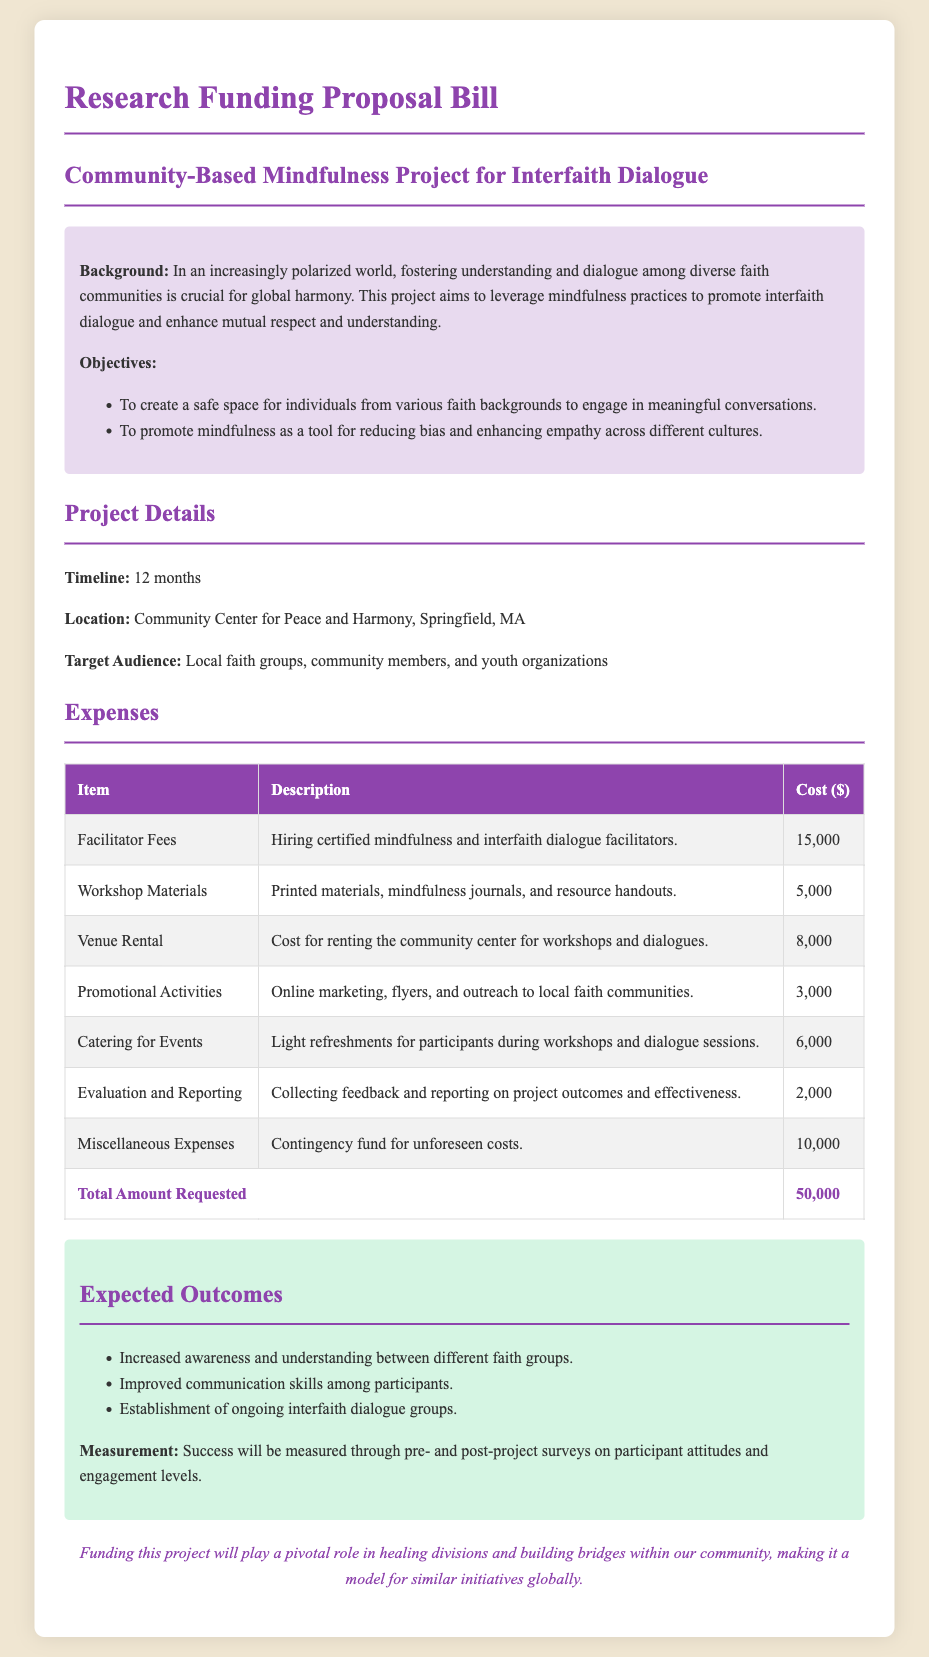What is the total amount requested? The total amount requested is clearly outlined in the expenses section of the document as the sum of all costs, which equals $50,000.
Answer: $50,000 What are the workshop materials? The workshop materials are described in the expenses section as printed materials, mindfulness journals, and resource handouts.
Answer: Printed materials, mindfulness journals, and resource handouts Where is the project located? The location of the project is stated in the document as the Community Center for Peace and Harmony, Springfield, MA.
Answer: Community Center for Peace and Harmony, Springfield, MA What is the target audience for the project? The target audience is specified in the project details as local faith groups, community members, and youth organizations.
Answer: Local faith groups, community members, and youth organizations Which item has the highest cost? The item with the highest cost is identified in the expenses table as facilitator fees, which amount to $15,000.
Answer: Facilitator Fees What is the purpose of promotional activities? The promotional activities are aimed at online marketing, flyers, and outreach to local faith communities, as detailed in the expenses section.
Answer: Online marketing, flyers, and outreach to local faith communities What is the timeline for the project? The timeline for the project is clearly mentioned in the document and specifies that it will last for 12 months.
Answer: 12 months What is the expected outcome concerning interfaith dialogue groups? The expected outcome notes the establishment of ongoing interfaith dialogue groups, as part of the projected benefits from the project.
Answer: Establishment of ongoing interfaith dialogue groups What type of document is this? This document is a research funding proposal bill specifically designed for a community-based mindfulness project.
Answer: Research funding proposal bill 